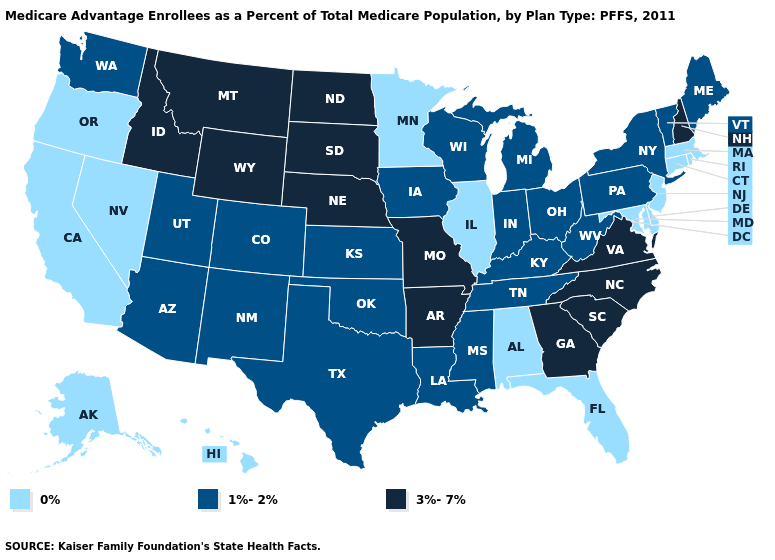Does Hawaii have the highest value in the USA?
Concise answer only. No. What is the value of Kansas?
Quick response, please. 1%-2%. How many symbols are there in the legend?
Give a very brief answer. 3. What is the highest value in the USA?
Quick response, please. 3%-7%. Does Colorado have a lower value than South Dakota?
Keep it brief. Yes. Name the states that have a value in the range 0%?
Write a very short answer. Alaska, Alabama, California, Connecticut, Delaware, Florida, Hawaii, Illinois, Massachusetts, Maryland, Minnesota, New Jersey, Nevada, Oregon, Rhode Island. What is the highest value in the Northeast ?
Keep it brief. 3%-7%. Name the states that have a value in the range 1%-2%?
Answer briefly. Arizona, Colorado, Iowa, Indiana, Kansas, Kentucky, Louisiana, Maine, Michigan, Mississippi, New Mexico, New York, Ohio, Oklahoma, Pennsylvania, Tennessee, Texas, Utah, Vermont, Washington, Wisconsin, West Virginia. Does the first symbol in the legend represent the smallest category?
Concise answer only. Yes. Does Wisconsin have the lowest value in the MidWest?
Write a very short answer. No. Which states have the lowest value in the USA?
Keep it brief. Alaska, Alabama, California, Connecticut, Delaware, Florida, Hawaii, Illinois, Massachusetts, Maryland, Minnesota, New Jersey, Nevada, Oregon, Rhode Island. Among the states that border Iowa , does Missouri have the lowest value?
Answer briefly. No. What is the highest value in the USA?
Keep it brief. 3%-7%. What is the lowest value in the USA?
Quick response, please. 0%. 